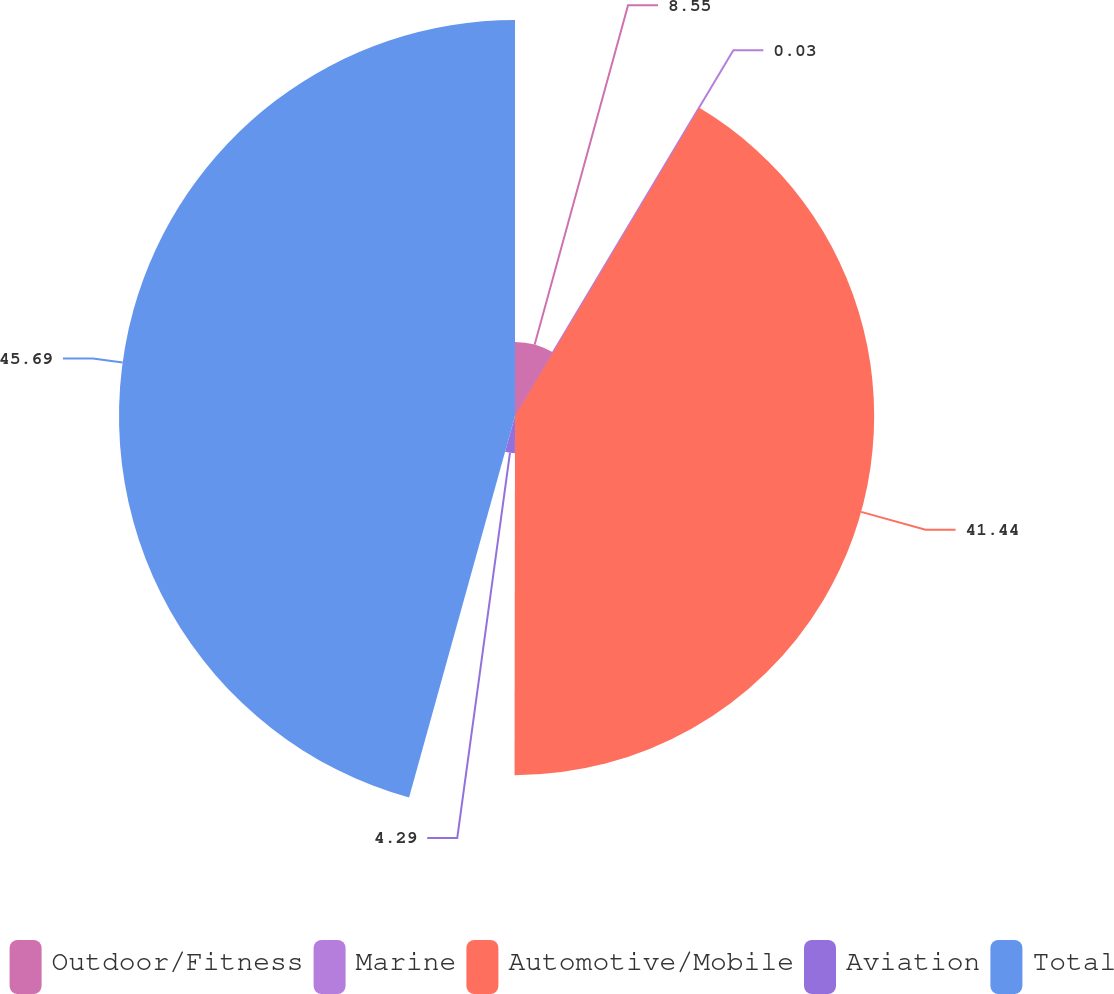Convert chart. <chart><loc_0><loc_0><loc_500><loc_500><pie_chart><fcel>Outdoor/Fitness<fcel>Marine<fcel>Automotive/Mobile<fcel>Aviation<fcel>Total<nl><fcel>8.55%<fcel>0.03%<fcel>41.44%<fcel>4.29%<fcel>45.69%<nl></chart> 